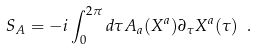Convert formula to latex. <formula><loc_0><loc_0><loc_500><loc_500>S _ { A } = - i \int _ { 0 } ^ { 2 \pi } d \tau A _ { a } ( X ^ { a } ) \partial _ { \tau } X ^ { a } ( \tau ) \ .</formula> 